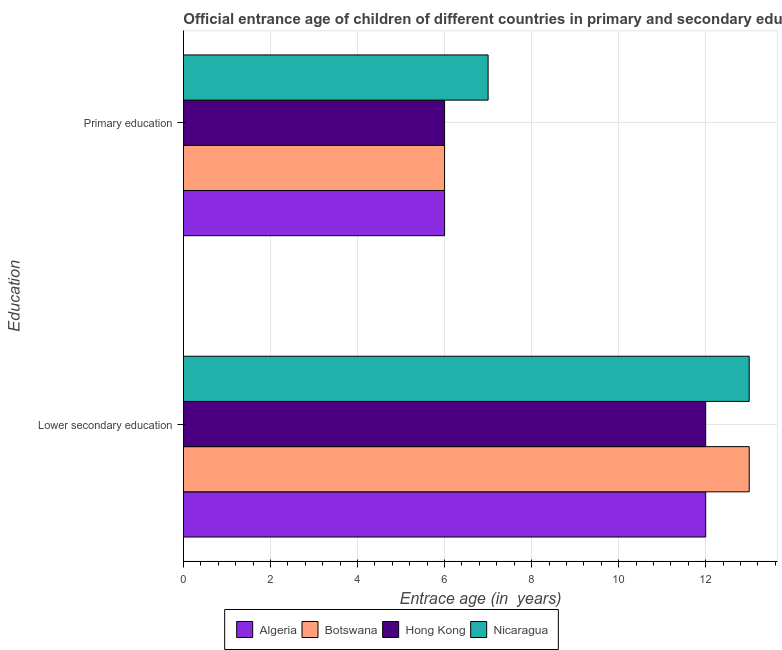How many different coloured bars are there?
Ensure brevity in your answer.  4. How many groups of bars are there?
Give a very brief answer. 2. Are the number of bars per tick equal to the number of legend labels?
Ensure brevity in your answer.  Yes. What is the label of the 1st group of bars from the top?
Your response must be concise. Primary education. What is the entrance age of children in lower secondary education in Hong Kong?
Provide a succinct answer. 12. Across all countries, what is the maximum entrance age of children in lower secondary education?
Offer a very short reply. 13. Across all countries, what is the minimum entrance age of chiildren in primary education?
Offer a terse response. 6. In which country was the entrance age of children in lower secondary education maximum?
Your answer should be very brief. Botswana. In which country was the entrance age of children in lower secondary education minimum?
Give a very brief answer. Algeria. What is the total entrance age of chiildren in primary education in the graph?
Ensure brevity in your answer.  25. What is the difference between the entrance age of children in lower secondary education in Hong Kong and that in Nicaragua?
Offer a very short reply. -1. What is the difference between the entrance age of chiildren in primary education in Nicaragua and the entrance age of children in lower secondary education in Algeria?
Offer a very short reply. -5. What is the average entrance age of chiildren in primary education per country?
Your response must be concise. 6.25. What is the difference between the entrance age of chiildren in primary education and entrance age of children in lower secondary education in Botswana?
Provide a succinct answer. -7. In how many countries, is the entrance age of chiildren in primary education greater than 8.4 years?
Your answer should be compact. 0. Is the entrance age of chiildren in primary education in Nicaragua less than that in Botswana?
Ensure brevity in your answer.  No. In how many countries, is the entrance age of children in lower secondary education greater than the average entrance age of children in lower secondary education taken over all countries?
Ensure brevity in your answer.  2. What does the 2nd bar from the top in Lower secondary education represents?
Make the answer very short. Hong Kong. What does the 1st bar from the bottom in Lower secondary education represents?
Your answer should be very brief. Algeria. How many countries are there in the graph?
Your response must be concise. 4. Does the graph contain any zero values?
Offer a terse response. No. Does the graph contain grids?
Your answer should be very brief. Yes. How are the legend labels stacked?
Keep it short and to the point. Horizontal. What is the title of the graph?
Ensure brevity in your answer.  Official entrance age of children of different countries in primary and secondary education. What is the label or title of the X-axis?
Offer a very short reply. Entrace age (in  years). What is the label or title of the Y-axis?
Your response must be concise. Education. What is the Entrace age (in  years) in Algeria in Lower secondary education?
Provide a succinct answer. 12. What is the Entrace age (in  years) of Botswana in Lower secondary education?
Make the answer very short. 13. What is the Entrace age (in  years) of Hong Kong in Lower secondary education?
Ensure brevity in your answer.  12. What is the Entrace age (in  years) of Nicaragua in Lower secondary education?
Keep it short and to the point. 13. What is the Entrace age (in  years) of Botswana in Primary education?
Your answer should be compact. 6. Across all Education, what is the maximum Entrace age (in  years) of Algeria?
Give a very brief answer. 12. Across all Education, what is the maximum Entrace age (in  years) of Botswana?
Your answer should be very brief. 13. Across all Education, what is the maximum Entrace age (in  years) of Hong Kong?
Offer a terse response. 12. Across all Education, what is the minimum Entrace age (in  years) of Algeria?
Offer a terse response. 6. Across all Education, what is the minimum Entrace age (in  years) of Botswana?
Provide a short and direct response. 6. Across all Education, what is the minimum Entrace age (in  years) of Nicaragua?
Ensure brevity in your answer.  7. What is the total Entrace age (in  years) of Botswana in the graph?
Offer a very short reply. 19. What is the total Entrace age (in  years) of Hong Kong in the graph?
Offer a terse response. 18. What is the difference between the Entrace age (in  years) in Hong Kong in Lower secondary education and that in Primary education?
Keep it short and to the point. 6. What is the difference between the Entrace age (in  years) of Nicaragua in Lower secondary education and that in Primary education?
Your answer should be very brief. 6. What is the difference between the Entrace age (in  years) in Algeria in Lower secondary education and the Entrace age (in  years) in Nicaragua in Primary education?
Offer a very short reply. 5. What is the difference between the Entrace age (in  years) of Botswana in Lower secondary education and the Entrace age (in  years) of Hong Kong in Primary education?
Your answer should be compact. 7. What is the difference between the Entrace age (in  years) of Botswana in Lower secondary education and the Entrace age (in  years) of Nicaragua in Primary education?
Offer a terse response. 6. What is the difference between the Entrace age (in  years) of Hong Kong in Lower secondary education and the Entrace age (in  years) of Nicaragua in Primary education?
Your response must be concise. 5. What is the average Entrace age (in  years) of Algeria per Education?
Make the answer very short. 9. What is the average Entrace age (in  years) in Hong Kong per Education?
Your response must be concise. 9. What is the average Entrace age (in  years) of Nicaragua per Education?
Your answer should be compact. 10. What is the difference between the Entrace age (in  years) in Algeria and Entrace age (in  years) in Botswana in Lower secondary education?
Give a very brief answer. -1. What is the difference between the Entrace age (in  years) of Algeria and Entrace age (in  years) of Hong Kong in Lower secondary education?
Your response must be concise. 0. What is the difference between the Entrace age (in  years) in Algeria and Entrace age (in  years) in Nicaragua in Lower secondary education?
Your response must be concise. -1. What is the difference between the Entrace age (in  years) of Botswana and Entrace age (in  years) of Hong Kong in Lower secondary education?
Keep it short and to the point. 1. What is the difference between the Entrace age (in  years) of Botswana and Entrace age (in  years) of Nicaragua in Lower secondary education?
Your answer should be very brief. 0. What is the difference between the Entrace age (in  years) in Hong Kong and Entrace age (in  years) in Nicaragua in Lower secondary education?
Provide a short and direct response. -1. What is the difference between the Entrace age (in  years) of Algeria and Entrace age (in  years) of Botswana in Primary education?
Offer a very short reply. 0. What is the ratio of the Entrace age (in  years) of Algeria in Lower secondary education to that in Primary education?
Offer a very short reply. 2. What is the ratio of the Entrace age (in  years) in Botswana in Lower secondary education to that in Primary education?
Your response must be concise. 2.17. What is the ratio of the Entrace age (in  years) of Hong Kong in Lower secondary education to that in Primary education?
Ensure brevity in your answer.  2. What is the ratio of the Entrace age (in  years) of Nicaragua in Lower secondary education to that in Primary education?
Ensure brevity in your answer.  1.86. What is the difference between the highest and the second highest Entrace age (in  years) of Algeria?
Make the answer very short. 6. What is the difference between the highest and the second highest Entrace age (in  years) of Nicaragua?
Offer a terse response. 6. What is the difference between the highest and the lowest Entrace age (in  years) in Algeria?
Offer a very short reply. 6. 